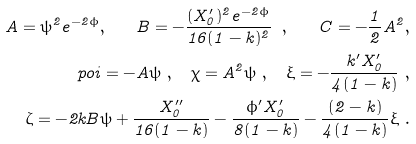<formula> <loc_0><loc_0><loc_500><loc_500>A = \psi ^ { 2 } e ^ { - 2 \phi } , \quad B = - \frac { ( X _ { 0 } ^ { \prime } ) ^ { 2 } e ^ { - 2 \phi } } { 1 6 ( 1 - k ) ^ { 2 } } \ , \quad C = - \frac { 1 } { 2 } A ^ { 2 } , \\ \ p o i = - A \psi \ , \quad \chi = A ^ { 2 } \psi \ , \quad \xi = - \frac { k ^ { \prime } X _ { 0 } ^ { \prime } } { 4 ( 1 - k ) } \ , \\ \zeta = - 2 k B \psi + \frac { X _ { 0 } ^ { \prime \prime } } { 1 6 ( 1 - k ) } - \frac { \phi ^ { \prime } X _ { 0 } ^ { \prime } } { 8 ( 1 - k ) } - \frac { ( 2 - k ) } { 4 ( 1 - k ) } \xi \ .</formula> 